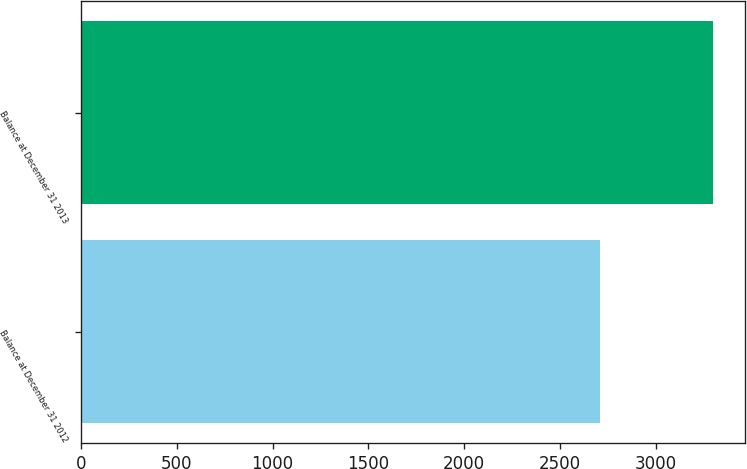<chart> <loc_0><loc_0><loc_500><loc_500><bar_chart><fcel>Balance at December 31 2012<fcel>Balance at December 31 2013<nl><fcel>2708<fcel>3298<nl></chart> 